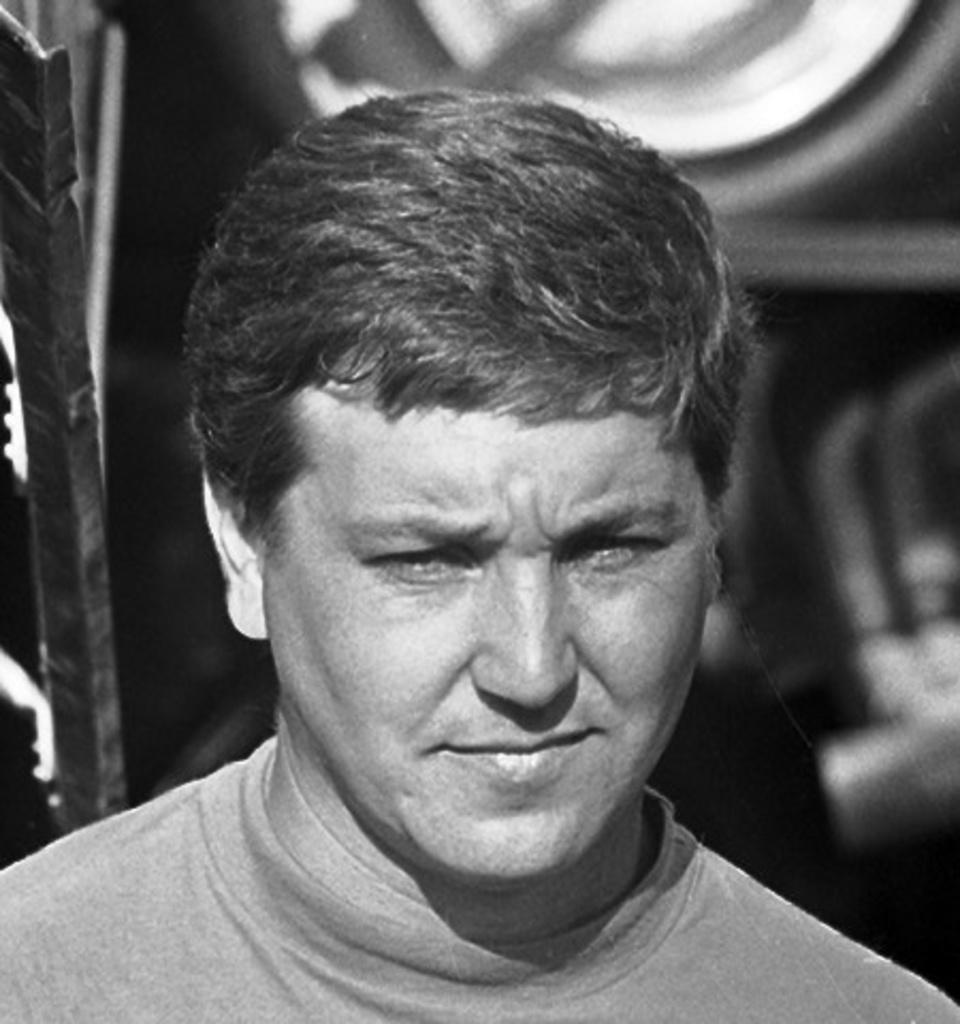What is the main subject of the image? There is a person's face in the image. Can you describe the background of the image? The background of the image is blurry. What color scheme is used in the image? The image is in black and white. What type of cable can be seen in the image? There is no cable present in the image; it features a person's face with a blurry background in black and white. What kind of border surrounds the image? The provided facts do not mention any border surrounding the image. 